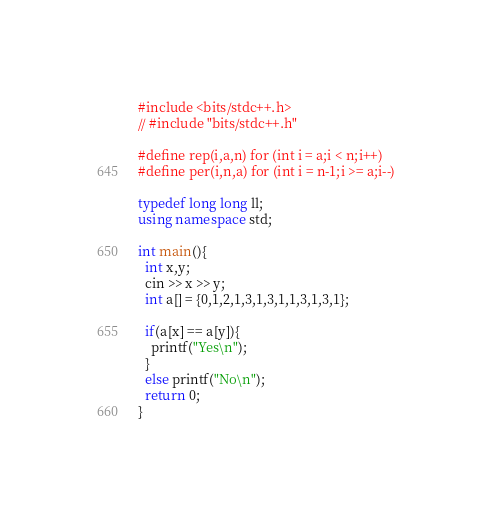<code> <loc_0><loc_0><loc_500><loc_500><_C++_>#include <bits/stdc++.h>
// #include "bits/stdc++.h"

#define rep(i,a,n) for (int i = a;i < n;i++)
#define per(i,n,a) for (int i = n-1;i >= a;i--)
 
typedef long long ll;
using namespace std;
 
int main(){
  int x,y;
  cin >> x >> y;
  int a[] = {0,1,2,1,3,1,3,1,1,3,1,3,1};

  if(a[x] == a[y]){
    printf("Yes\n");
  }
  else printf("No\n");
  return 0;
}</code> 